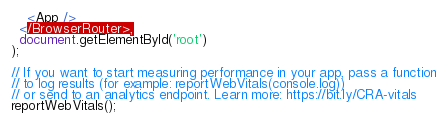<code> <loc_0><loc_0><loc_500><loc_500><_TypeScript_>    <App />
  </BrowserRouter>,
  document.getElementById('root')
);

// If you want to start measuring performance in your app, pass a function
// to log results (for example: reportWebVitals(console.log))
// or send to an analytics endpoint. Learn more: https://bit.ly/CRA-vitals
reportWebVitals();
</code> 